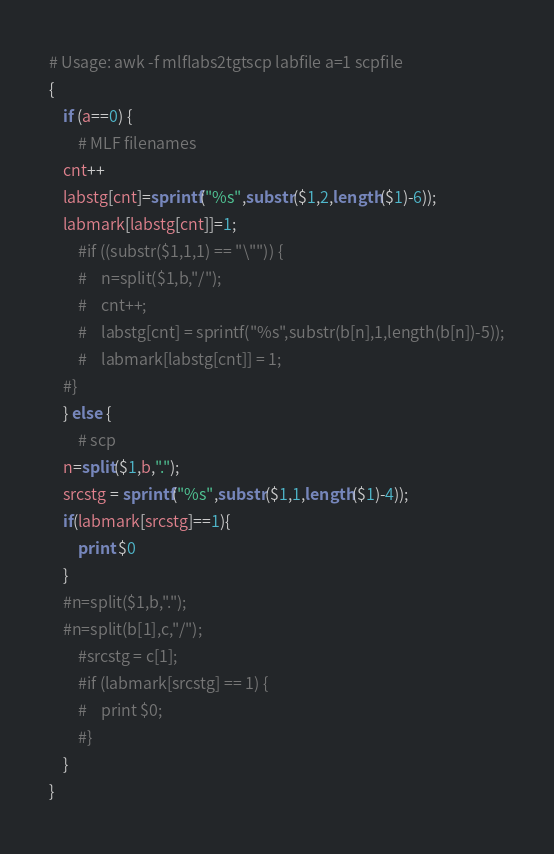Convert code to text. <code><loc_0><loc_0><loc_500><loc_500><_Awk_># Usage: awk -f mlflabs2tgtscp labfile a=1 scpfile
{
    if (a==0) {
        # MLF filenames
	cnt++
	labstg[cnt]=sprintf("%s",substr($1,2,length($1)-6));
	labmark[labstg[cnt]]=1;
        #if ((substr($1,1,1) == "\"")) {
        #    n=split($1,b,"/");      
        #    cnt++;
        #    labstg[cnt] = sprintf("%s",substr(b[n],1,length(b[n])-5));
        #    labmark[labstg[cnt]] = 1;
	#}
    } else {
        # scp
	n=split($1,b,".");
	srcstg = sprintf("%s",substr($1,1,length($1)-4));
	if(labmark[srcstg]==1){
	    print $0
	}
	#n=split($1,b,".");
	#n=split(b[1],c,"/");
        #srcstg = c[1];
        #if (labmark[srcstg] == 1) {
        #    print $0;
        #}
    }
}
</code> 